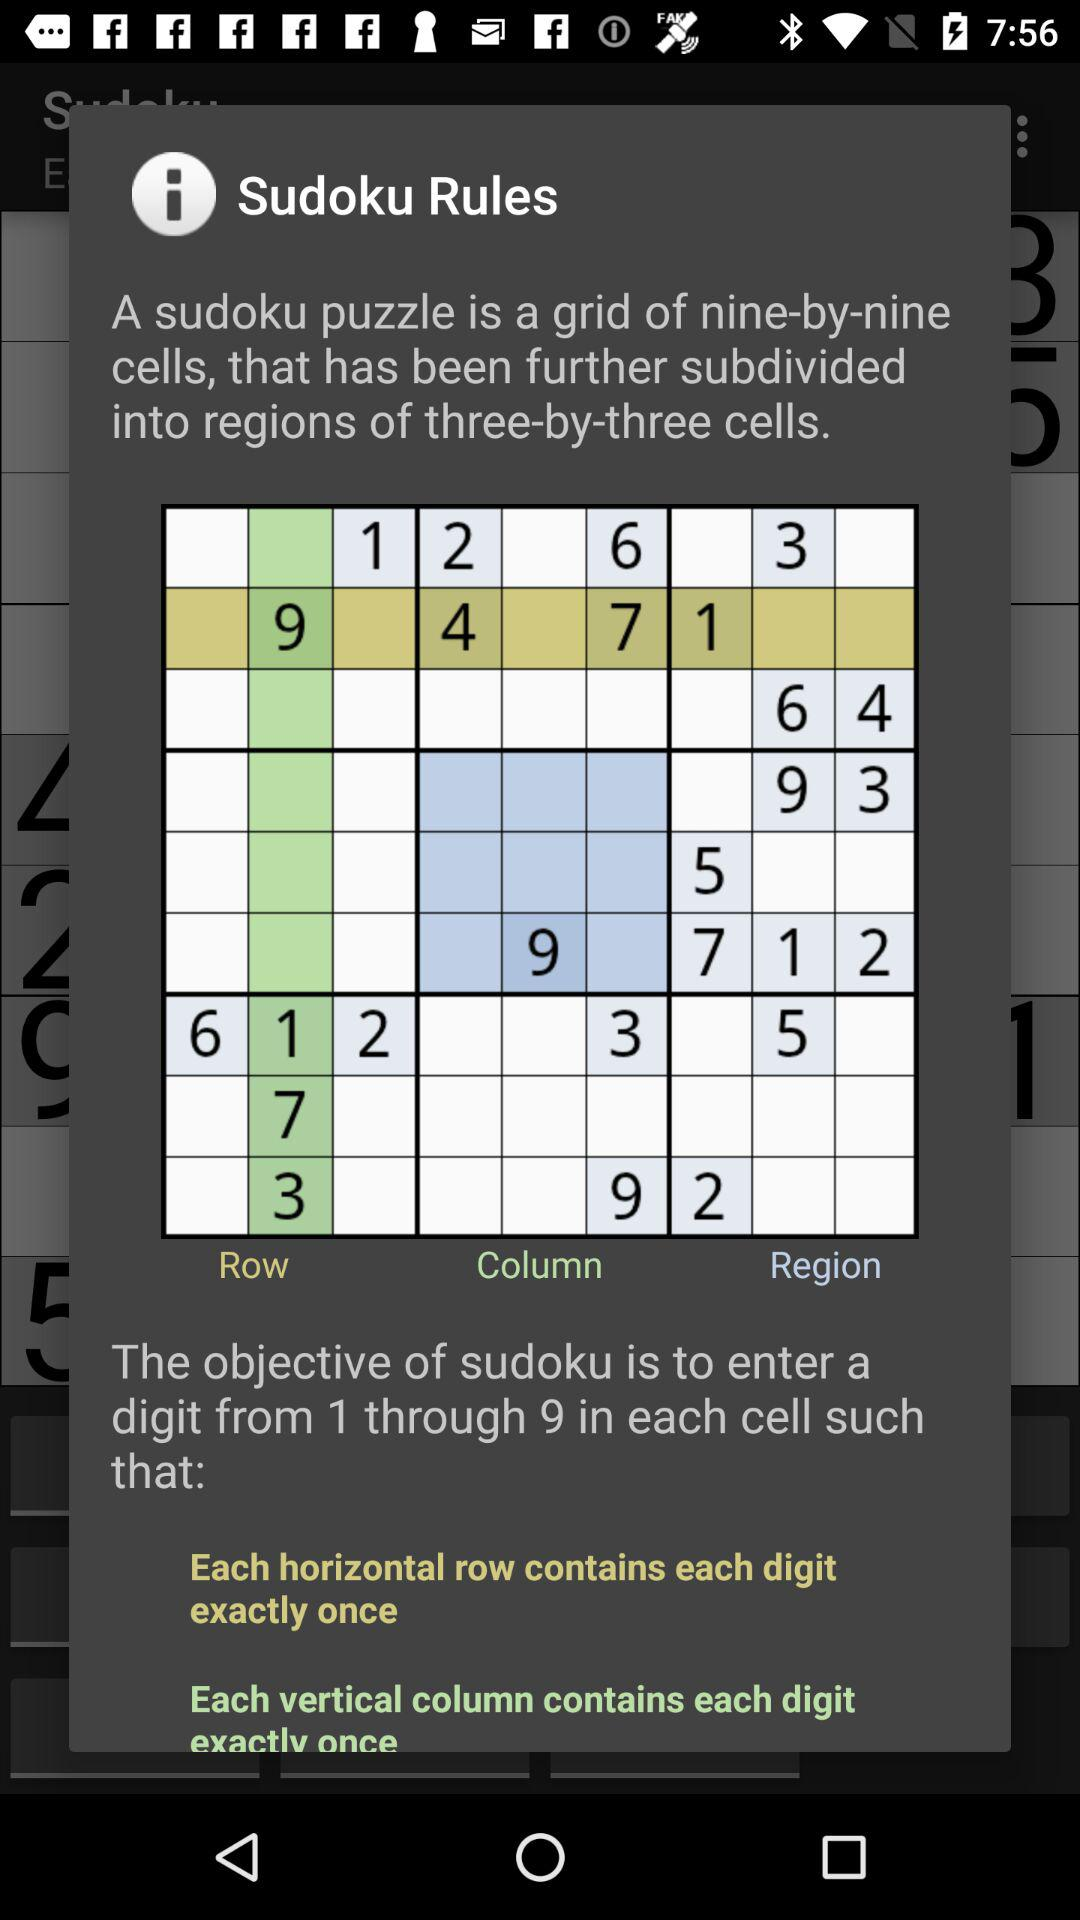How many rows are in the sudoku puzzle?
Answer the question using a single word or phrase. 9 